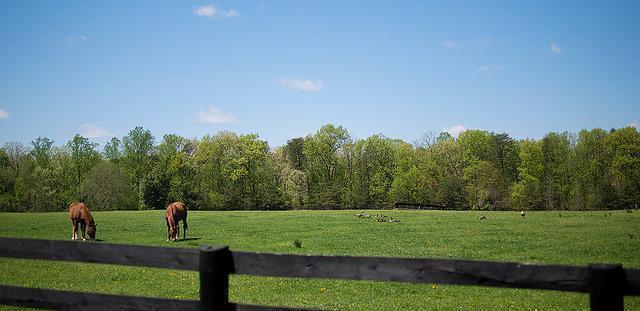What other type of large animal might be found in this environment?
From the following four choices, select the correct answer to address the question.
Options: Dog, cow, elephant, tiger. Cow. 